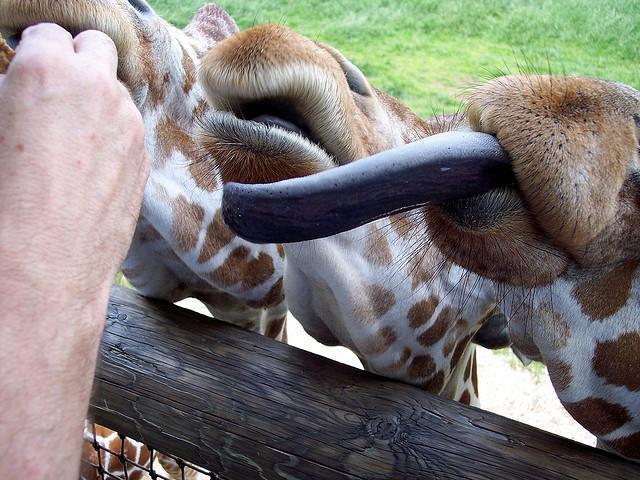How many giraffes can you see?
Give a very brief answer. 3. How many large elephants are standing?
Give a very brief answer. 0. 